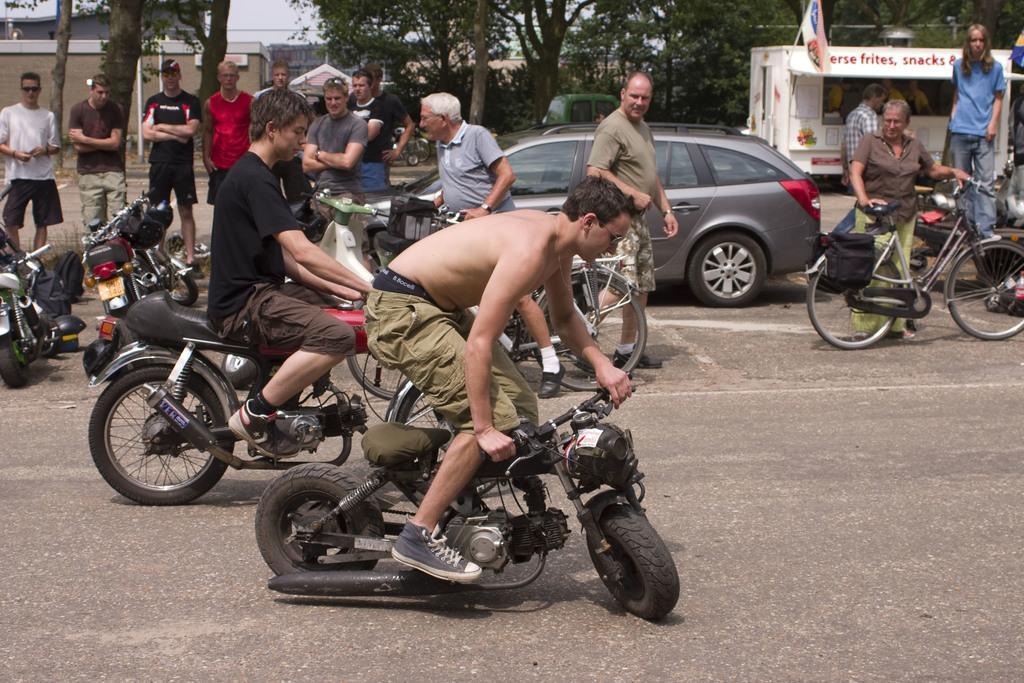In one or two sentences, can you explain what this image depicts? In this picture we can see group of people where some people are riding bike and others are holding bicycles and in the background we can see trees, building, car, some vehicle, flag is attached to it. 